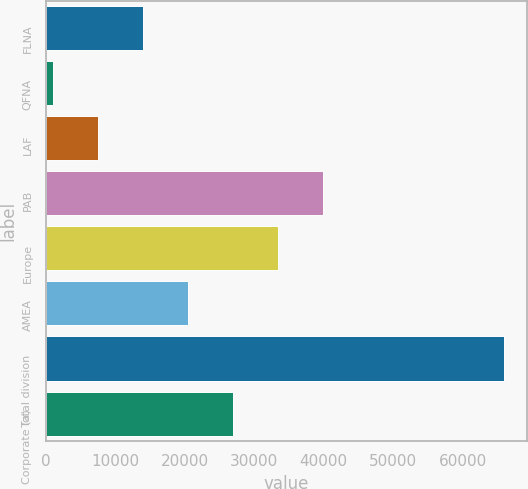<chart> <loc_0><loc_0><loc_500><loc_500><bar_chart><fcel>FLNA<fcel>QFNA<fcel>LAF<fcel>PAB<fcel>Europe<fcel>AMEA<fcel>Total division<fcel>Corporate (a)<nl><fcel>13971.6<fcel>983<fcel>7477.3<fcel>39948.8<fcel>33454.5<fcel>20465.9<fcel>65926<fcel>26960.2<nl></chart> 